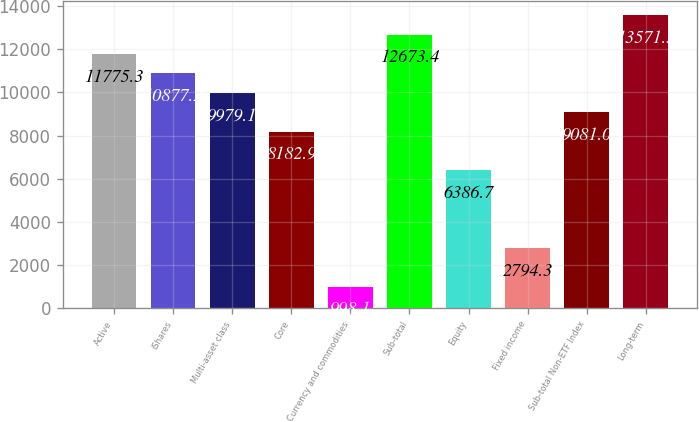Convert chart. <chart><loc_0><loc_0><loc_500><loc_500><bar_chart><fcel>Active<fcel>iShares<fcel>Multi-asset class<fcel>Core<fcel>Currency and commodities<fcel>Sub-total<fcel>Equity<fcel>Fixed income<fcel>Sub-total Non-ETF Index<fcel>Long-term<nl><fcel>11775.3<fcel>10877.2<fcel>9979.1<fcel>8182.9<fcel>998.1<fcel>12673.4<fcel>6386.7<fcel>2794.3<fcel>9081<fcel>13571.5<nl></chart> 